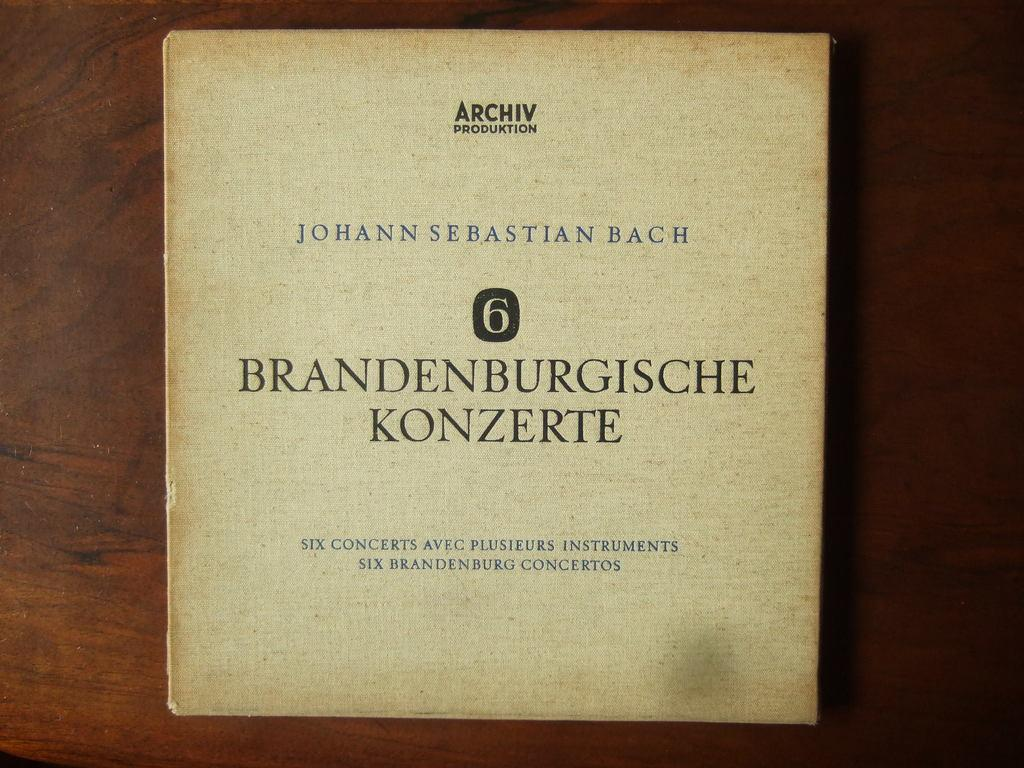Provide a one-sentence caption for the provided image. Brandenburgische konzerte book about six concerts aveg plus instruments. 